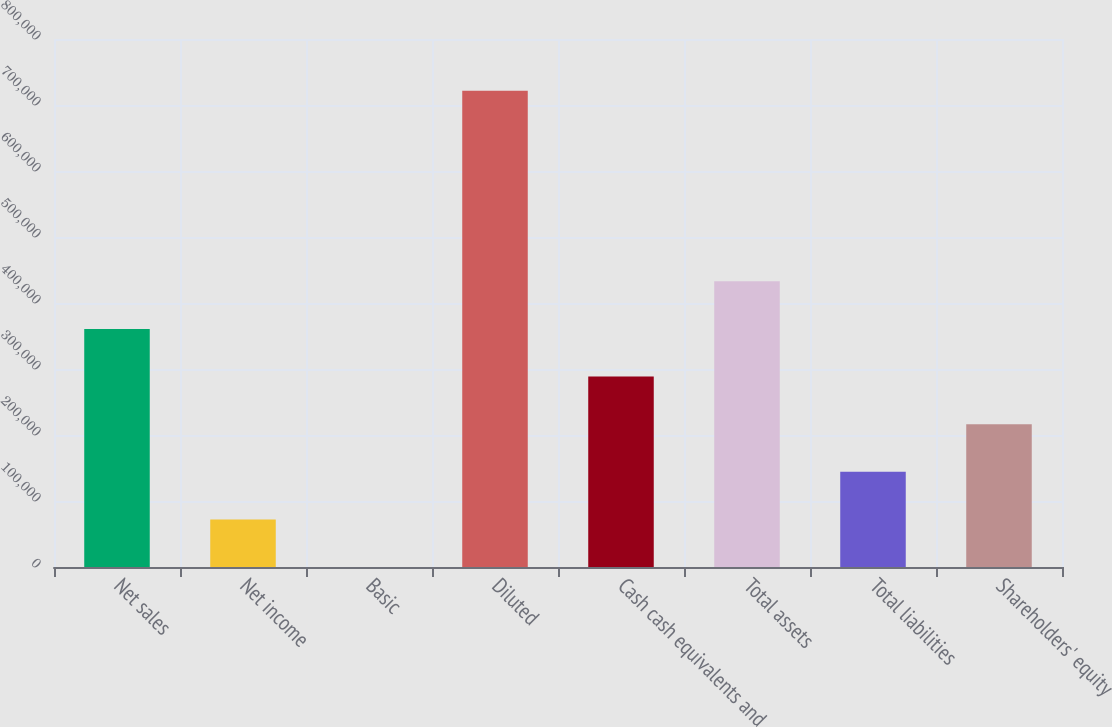Convert chart to OTSL. <chart><loc_0><loc_0><loc_500><loc_500><bar_chart><fcel>Net sales<fcel>Net income<fcel>Basic<fcel>Diluted<fcel>Cash cash equivalents and<fcel>Total assets<fcel>Total liabilities<fcel>Shareholders' equity<nl><fcel>360723<fcel>72144.6<fcel>0.06<fcel>721445<fcel>288578<fcel>432867<fcel>144289<fcel>216434<nl></chart> 